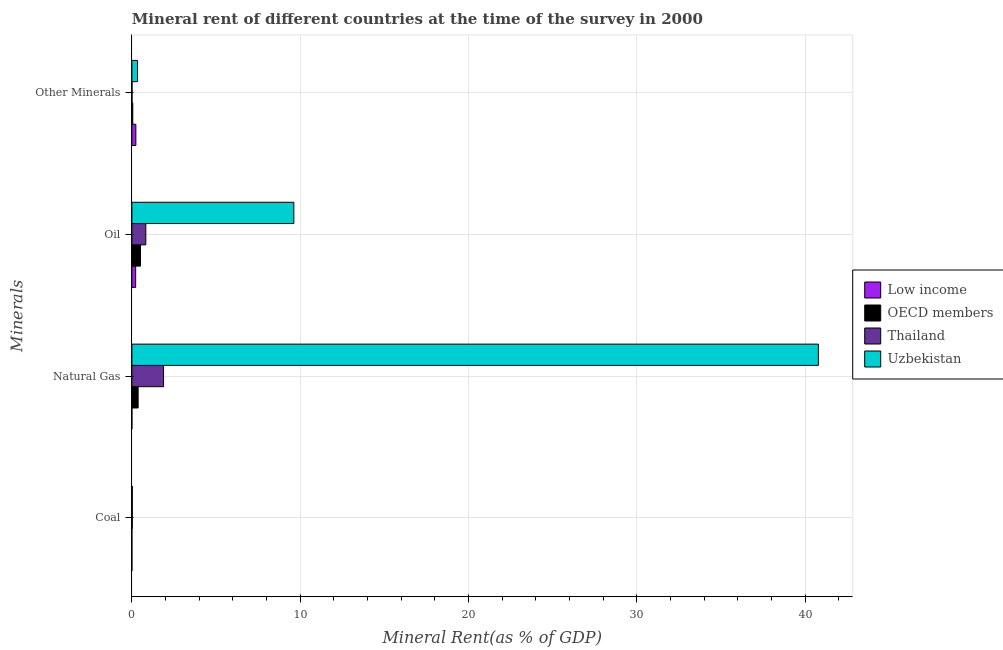How many different coloured bars are there?
Your answer should be compact. 4. Are the number of bars per tick equal to the number of legend labels?
Your response must be concise. Yes. Are the number of bars on each tick of the Y-axis equal?
Keep it short and to the point. Yes. How many bars are there on the 3rd tick from the bottom?
Give a very brief answer. 4. What is the label of the 1st group of bars from the top?
Give a very brief answer. Other Minerals. What is the oil rent in OECD members?
Offer a terse response. 0.51. Across all countries, what is the maximum coal rent?
Provide a succinct answer. 0.03. Across all countries, what is the minimum  rent of other minerals?
Offer a terse response. 0.01. In which country was the  rent of other minerals maximum?
Give a very brief answer. Uzbekistan. What is the total natural gas rent in the graph?
Your answer should be compact. 43.04. What is the difference between the oil rent in Low income and that in Thailand?
Keep it short and to the point. -0.6. What is the difference between the  rent of other minerals in Low income and the natural gas rent in Thailand?
Keep it short and to the point. -1.64. What is the average  rent of other minerals per country?
Make the answer very short. 0.16. What is the difference between the oil rent and  rent of other minerals in OECD members?
Make the answer very short. 0.46. What is the ratio of the coal rent in Thailand to that in Uzbekistan?
Your response must be concise. 1. Is the  rent of other minerals in Low income less than that in Uzbekistan?
Offer a terse response. Yes. What is the difference between the highest and the second highest natural gas rent?
Give a very brief answer. 38.9. What is the difference between the highest and the lowest coal rent?
Your answer should be compact. 0.03. Is the sum of the oil rent in Low income and OECD members greater than the maximum natural gas rent across all countries?
Offer a terse response. No. What does the 3rd bar from the top in Oil represents?
Provide a short and direct response. OECD members. What does the 1st bar from the bottom in Oil represents?
Your answer should be compact. Low income. Does the graph contain grids?
Keep it short and to the point. Yes. Where does the legend appear in the graph?
Ensure brevity in your answer.  Center right. What is the title of the graph?
Offer a very short reply. Mineral rent of different countries at the time of the survey in 2000. Does "Azerbaijan" appear as one of the legend labels in the graph?
Keep it short and to the point. No. What is the label or title of the X-axis?
Offer a very short reply. Mineral Rent(as % of GDP). What is the label or title of the Y-axis?
Provide a short and direct response. Minerals. What is the Mineral Rent(as % of GDP) of Low income in Coal?
Give a very brief answer. 3.43081541094935e-5. What is the Mineral Rent(as % of GDP) in OECD members in Coal?
Offer a terse response. 0. What is the Mineral Rent(as % of GDP) of Thailand in Coal?
Provide a short and direct response. 0.03. What is the Mineral Rent(as % of GDP) in Uzbekistan in Coal?
Keep it short and to the point. 0.03. What is the Mineral Rent(as % of GDP) in Low income in Natural Gas?
Provide a succinct answer. 0. What is the Mineral Rent(as % of GDP) of OECD members in Natural Gas?
Keep it short and to the point. 0.37. What is the Mineral Rent(as % of GDP) in Thailand in Natural Gas?
Your response must be concise. 1.88. What is the Mineral Rent(as % of GDP) in Uzbekistan in Natural Gas?
Offer a very short reply. 40.78. What is the Mineral Rent(as % of GDP) of Low income in Oil?
Make the answer very short. 0.22. What is the Mineral Rent(as % of GDP) in OECD members in Oil?
Your answer should be compact. 0.51. What is the Mineral Rent(as % of GDP) of Thailand in Oil?
Provide a succinct answer. 0.83. What is the Mineral Rent(as % of GDP) in Uzbekistan in Oil?
Provide a succinct answer. 9.62. What is the Mineral Rent(as % of GDP) in Low income in Other Minerals?
Give a very brief answer. 0.24. What is the Mineral Rent(as % of GDP) of OECD members in Other Minerals?
Your answer should be compact. 0.05. What is the Mineral Rent(as % of GDP) of Thailand in Other Minerals?
Give a very brief answer. 0.01. What is the Mineral Rent(as % of GDP) of Uzbekistan in Other Minerals?
Your response must be concise. 0.34. Across all Minerals, what is the maximum Mineral Rent(as % of GDP) of Low income?
Offer a very short reply. 0.24. Across all Minerals, what is the maximum Mineral Rent(as % of GDP) of OECD members?
Provide a succinct answer. 0.51. Across all Minerals, what is the maximum Mineral Rent(as % of GDP) of Thailand?
Offer a very short reply. 1.88. Across all Minerals, what is the maximum Mineral Rent(as % of GDP) of Uzbekistan?
Offer a very short reply. 40.78. Across all Minerals, what is the minimum Mineral Rent(as % of GDP) of Low income?
Your answer should be compact. 3.43081541094935e-5. Across all Minerals, what is the minimum Mineral Rent(as % of GDP) in OECD members?
Make the answer very short. 0. Across all Minerals, what is the minimum Mineral Rent(as % of GDP) in Thailand?
Give a very brief answer. 0.01. Across all Minerals, what is the minimum Mineral Rent(as % of GDP) of Uzbekistan?
Ensure brevity in your answer.  0.03. What is the total Mineral Rent(as % of GDP) in Low income in the graph?
Your answer should be compact. 0.46. What is the total Mineral Rent(as % of GDP) in OECD members in the graph?
Offer a terse response. 0.94. What is the total Mineral Rent(as % of GDP) of Thailand in the graph?
Provide a short and direct response. 2.74. What is the total Mineral Rent(as % of GDP) of Uzbekistan in the graph?
Give a very brief answer. 50.77. What is the difference between the Mineral Rent(as % of GDP) of Low income in Coal and that in Natural Gas?
Give a very brief answer. -0. What is the difference between the Mineral Rent(as % of GDP) of OECD members in Coal and that in Natural Gas?
Your answer should be compact. -0.37. What is the difference between the Mineral Rent(as % of GDP) of Thailand in Coal and that in Natural Gas?
Give a very brief answer. -1.86. What is the difference between the Mineral Rent(as % of GDP) in Uzbekistan in Coal and that in Natural Gas?
Provide a succinct answer. -40.76. What is the difference between the Mineral Rent(as % of GDP) of Low income in Coal and that in Oil?
Provide a short and direct response. -0.22. What is the difference between the Mineral Rent(as % of GDP) in OECD members in Coal and that in Oil?
Your response must be concise. -0.51. What is the difference between the Mineral Rent(as % of GDP) of Thailand in Coal and that in Oil?
Offer a very short reply. -0.8. What is the difference between the Mineral Rent(as % of GDP) in Uzbekistan in Coal and that in Oil?
Provide a succinct answer. -9.6. What is the difference between the Mineral Rent(as % of GDP) in Low income in Coal and that in Other Minerals?
Keep it short and to the point. -0.24. What is the difference between the Mineral Rent(as % of GDP) in OECD members in Coal and that in Other Minerals?
Give a very brief answer. -0.05. What is the difference between the Mineral Rent(as % of GDP) of Thailand in Coal and that in Other Minerals?
Ensure brevity in your answer.  0.02. What is the difference between the Mineral Rent(as % of GDP) in Uzbekistan in Coal and that in Other Minerals?
Ensure brevity in your answer.  -0.31. What is the difference between the Mineral Rent(as % of GDP) of Low income in Natural Gas and that in Oil?
Your response must be concise. -0.22. What is the difference between the Mineral Rent(as % of GDP) of OECD members in Natural Gas and that in Oil?
Give a very brief answer. -0.14. What is the difference between the Mineral Rent(as % of GDP) of Thailand in Natural Gas and that in Oil?
Provide a succinct answer. 1.05. What is the difference between the Mineral Rent(as % of GDP) in Uzbekistan in Natural Gas and that in Oil?
Provide a short and direct response. 31.16. What is the difference between the Mineral Rent(as % of GDP) in Low income in Natural Gas and that in Other Minerals?
Make the answer very short. -0.24. What is the difference between the Mineral Rent(as % of GDP) of OECD members in Natural Gas and that in Other Minerals?
Keep it short and to the point. 0.32. What is the difference between the Mineral Rent(as % of GDP) in Thailand in Natural Gas and that in Other Minerals?
Provide a short and direct response. 1.87. What is the difference between the Mineral Rent(as % of GDP) of Uzbekistan in Natural Gas and that in Other Minerals?
Offer a very short reply. 40.45. What is the difference between the Mineral Rent(as % of GDP) in Low income in Oil and that in Other Minerals?
Provide a short and direct response. -0.01. What is the difference between the Mineral Rent(as % of GDP) of OECD members in Oil and that in Other Minerals?
Your answer should be compact. 0.46. What is the difference between the Mineral Rent(as % of GDP) in Thailand in Oil and that in Other Minerals?
Offer a very short reply. 0.82. What is the difference between the Mineral Rent(as % of GDP) in Uzbekistan in Oil and that in Other Minerals?
Give a very brief answer. 9.29. What is the difference between the Mineral Rent(as % of GDP) in Low income in Coal and the Mineral Rent(as % of GDP) in OECD members in Natural Gas?
Your response must be concise. -0.37. What is the difference between the Mineral Rent(as % of GDP) of Low income in Coal and the Mineral Rent(as % of GDP) of Thailand in Natural Gas?
Ensure brevity in your answer.  -1.88. What is the difference between the Mineral Rent(as % of GDP) of Low income in Coal and the Mineral Rent(as % of GDP) of Uzbekistan in Natural Gas?
Give a very brief answer. -40.78. What is the difference between the Mineral Rent(as % of GDP) in OECD members in Coal and the Mineral Rent(as % of GDP) in Thailand in Natural Gas?
Provide a succinct answer. -1.88. What is the difference between the Mineral Rent(as % of GDP) of OECD members in Coal and the Mineral Rent(as % of GDP) of Uzbekistan in Natural Gas?
Offer a terse response. -40.78. What is the difference between the Mineral Rent(as % of GDP) of Thailand in Coal and the Mineral Rent(as % of GDP) of Uzbekistan in Natural Gas?
Offer a very short reply. -40.76. What is the difference between the Mineral Rent(as % of GDP) in Low income in Coal and the Mineral Rent(as % of GDP) in OECD members in Oil?
Keep it short and to the point. -0.51. What is the difference between the Mineral Rent(as % of GDP) in Low income in Coal and the Mineral Rent(as % of GDP) in Thailand in Oil?
Ensure brevity in your answer.  -0.83. What is the difference between the Mineral Rent(as % of GDP) of Low income in Coal and the Mineral Rent(as % of GDP) of Uzbekistan in Oil?
Keep it short and to the point. -9.62. What is the difference between the Mineral Rent(as % of GDP) in OECD members in Coal and the Mineral Rent(as % of GDP) in Thailand in Oil?
Offer a terse response. -0.83. What is the difference between the Mineral Rent(as % of GDP) in OECD members in Coal and the Mineral Rent(as % of GDP) in Uzbekistan in Oil?
Your response must be concise. -9.62. What is the difference between the Mineral Rent(as % of GDP) of Thailand in Coal and the Mineral Rent(as % of GDP) of Uzbekistan in Oil?
Your response must be concise. -9.6. What is the difference between the Mineral Rent(as % of GDP) in Low income in Coal and the Mineral Rent(as % of GDP) in OECD members in Other Minerals?
Offer a terse response. -0.05. What is the difference between the Mineral Rent(as % of GDP) in Low income in Coal and the Mineral Rent(as % of GDP) in Thailand in Other Minerals?
Your answer should be compact. -0.01. What is the difference between the Mineral Rent(as % of GDP) of Low income in Coal and the Mineral Rent(as % of GDP) of Uzbekistan in Other Minerals?
Your answer should be compact. -0.34. What is the difference between the Mineral Rent(as % of GDP) in OECD members in Coal and the Mineral Rent(as % of GDP) in Thailand in Other Minerals?
Your answer should be very brief. -0.01. What is the difference between the Mineral Rent(as % of GDP) of OECD members in Coal and the Mineral Rent(as % of GDP) of Uzbekistan in Other Minerals?
Keep it short and to the point. -0.34. What is the difference between the Mineral Rent(as % of GDP) of Thailand in Coal and the Mineral Rent(as % of GDP) of Uzbekistan in Other Minerals?
Offer a very short reply. -0.31. What is the difference between the Mineral Rent(as % of GDP) of Low income in Natural Gas and the Mineral Rent(as % of GDP) of OECD members in Oil?
Your answer should be compact. -0.51. What is the difference between the Mineral Rent(as % of GDP) of Low income in Natural Gas and the Mineral Rent(as % of GDP) of Thailand in Oil?
Provide a short and direct response. -0.83. What is the difference between the Mineral Rent(as % of GDP) in Low income in Natural Gas and the Mineral Rent(as % of GDP) in Uzbekistan in Oil?
Keep it short and to the point. -9.62. What is the difference between the Mineral Rent(as % of GDP) of OECD members in Natural Gas and the Mineral Rent(as % of GDP) of Thailand in Oil?
Your response must be concise. -0.46. What is the difference between the Mineral Rent(as % of GDP) of OECD members in Natural Gas and the Mineral Rent(as % of GDP) of Uzbekistan in Oil?
Offer a very short reply. -9.25. What is the difference between the Mineral Rent(as % of GDP) of Thailand in Natural Gas and the Mineral Rent(as % of GDP) of Uzbekistan in Oil?
Provide a short and direct response. -7.74. What is the difference between the Mineral Rent(as % of GDP) of Low income in Natural Gas and the Mineral Rent(as % of GDP) of OECD members in Other Minerals?
Make the answer very short. -0.05. What is the difference between the Mineral Rent(as % of GDP) in Low income in Natural Gas and the Mineral Rent(as % of GDP) in Thailand in Other Minerals?
Keep it short and to the point. -0.01. What is the difference between the Mineral Rent(as % of GDP) of Low income in Natural Gas and the Mineral Rent(as % of GDP) of Uzbekistan in Other Minerals?
Make the answer very short. -0.34. What is the difference between the Mineral Rent(as % of GDP) in OECD members in Natural Gas and the Mineral Rent(as % of GDP) in Thailand in Other Minerals?
Your answer should be compact. 0.36. What is the difference between the Mineral Rent(as % of GDP) of OECD members in Natural Gas and the Mineral Rent(as % of GDP) of Uzbekistan in Other Minerals?
Provide a succinct answer. 0.04. What is the difference between the Mineral Rent(as % of GDP) in Thailand in Natural Gas and the Mineral Rent(as % of GDP) in Uzbekistan in Other Minerals?
Your answer should be compact. 1.55. What is the difference between the Mineral Rent(as % of GDP) in Low income in Oil and the Mineral Rent(as % of GDP) in OECD members in Other Minerals?
Your answer should be compact. 0.17. What is the difference between the Mineral Rent(as % of GDP) in Low income in Oil and the Mineral Rent(as % of GDP) in Thailand in Other Minerals?
Your response must be concise. 0.21. What is the difference between the Mineral Rent(as % of GDP) of Low income in Oil and the Mineral Rent(as % of GDP) of Uzbekistan in Other Minerals?
Ensure brevity in your answer.  -0.11. What is the difference between the Mineral Rent(as % of GDP) of OECD members in Oil and the Mineral Rent(as % of GDP) of Thailand in Other Minerals?
Ensure brevity in your answer.  0.5. What is the difference between the Mineral Rent(as % of GDP) in OECD members in Oil and the Mineral Rent(as % of GDP) in Uzbekistan in Other Minerals?
Offer a very short reply. 0.18. What is the difference between the Mineral Rent(as % of GDP) of Thailand in Oil and the Mineral Rent(as % of GDP) of Uzbekistan in Other Minerals?
Your answer should be very brief. 0.49. What is the average Mineral Rent(as % of GDP) in Low income per Minerals?
Provide a succinct answer. 0.12. What is the average Mineral Rent(as % of GDP) in OECD members per Minerals?
Keep it short and to the point. 0.23. What is the average Mineral Rent(as % of GDP) in Thailand per Minerals?
Provide a short and direct response. 0.69. What is the average Mineral Rent(as % of GDP) of Uzbekistan per Minerals?
Make the answer very short. 12.69. What is the difference between the Mineral Rent(as % of GDP) in Low income and Mineral Rent(as % of GDP) in OECD members in Coal?
Ensure brevity in your answer.  -0. What is the difference between the Mineral Rent(as % of GDP) in Low income and Mineral Rent(as % of GDP) in Thailand in Coal?
Your answer should be very brief. -0.03. What is the difference between the Mineral Rent(as % of GDP) of Low income and Mineral Rent(as % of GDP) of Uzbekistan in Coal?
Give a very brief answer. -0.03. What is the difference between the Mineral Rent(as % of GDP) in OECD members and Mineral Rent(as % of GDP) in Thailand in Coal?
Your answer should be very brief. -0.03. What is the difference between the Mineral Rent(as % of GDP) in OECD members and Mineral Rent(as % of GDP) in Uzbekistan in Coal?
Your answer should be very brief. -0.03. What is the difference between the Mineral Rent(as % of GDP) in Thailand and Mineral Rent(as % of GDP) in Uzbekistan in Coal?
Give a very brief answer. -0. What is the difference between the Mineral Rent(as % of GDP) of Low income and Mineral Rent(as % of GDP) of OECD members in Natural Gas?
Your answer should be very brief. -0.37. What is the difference between the Mineral Rent(as % of GDP) of Low income and Mineral Rent(as % of GDP) of Thailand in Natural Gas?
Ensure brevity in your answer.  -1.88. What is the difference between the Mineral Rent(as % of GDP) in Low income and Mineral Rent(as % of GDP) in Uzbekistan in Natural Gas?
Ensure brevity in your answer.  -40.78. What is the difference between the Mineral Rent(as % of GDP) of OECD members and Mineral Rent(as % of GDP) of Thailand in Natural Gas?
Provide a succinct answer. -1.51. What is the difference between the Mineral Rent(as % of GDP) in OECD members and Mineral Rent(as % of GDP) in Uzbekistan in Natural Gas?
Give a very brief answer. -40.41. What is the difference between the Mineral Rent(as % of GDP) in Thailand and Mineral Rent(as % of GDP) in Uzbekistan in Natural Gas?
Offer a terse response. -38.9. What is the difference between the Mineral Rent(as % of GDP) in Low income and Mineral Rent(as % of GDP) in OECD members in Oil?
Your answer should be very brief. -0.29. What is the difference between the Mineral Rent(as % of GDP) of Low income and Mineral Rent(as % of GDP) of Thailand in Oil?
Provide a succinct answer. -0.6. What is the difference between the Mineral Rent(as % of GDP) in Low income and Mineral Rent(as % of GDP) in Uzbekistan in Oil?
Ensure brevity in your answer.  -9.4. What is the difference between the Mineral Rent(as % of GDP) of OECD members and Mineral Rent(as % of GDP) of Thailand in Oil?
Ensure brevity in your answer.  -0.32. What is the difference between the Mineral Rent(as % of GDP) of OECD members and Mineral Rent(as % of GDP) of Uzbekistan in Oil?
Offer a terse response. -9.11. What is the difference between the Mineral Rent(as % of GDP) in Thailand and Mineral Rent(as % of GDP) in Uzbekistan in Oil?
Offer a terse response. -8.79. What is the difference between the Mineral Rent(as % of GDP) in Low income and Mineral Rent(as % of GDP) in OECD members in Other Minerals?
Make the answer very short. 0.18. What is the difference between the Mineral Rent(as % of GDP) of Low income and Mineral Rent(as % of GDP) of Thailand in Other Minerals?
Your answer should be very brief. 0.23. What is the difference between the Mineral Rent(as % of GDP) of Low income and Mineral Rent(as % of GDP) of Uzbekistan in Other Minerals?
Your response must be concise. -0.1. What is the difference between the Mineral Rent(as % of GDP) of OECD members and Mineral Rent(as % of GDP) of Thailand in Other Minerals?
Ensure brevity in your answer.  0.04. What is the difference between the Mineral Rent(as % of GDP) in OECD members and Mineral Rent(as % of GDP) in Uzbekistan in Other Minerals?
Provide a succinct answer. -0.28. What is the difference between the Mineral Rent(as % of GDP) in Thailand and Mineral Rent(as % of GDP) in Uzbekistan in Other Minerals?
Offer a very short reply. -0.33. What is the ratio of the Mineral Rent(as % of GDP) in Low income in Coal to that in Natural Gas?
Your response must be concise. 0.23. What is the ratio of the Mineral Rent(as % of GDP) of Thailand in Coal to that in Natural Gas?
Provide a short and direct response. 0.01. What is the ratio of the Mineral Rent(as % of GDP) in Uzbekistan in Coal to that in Natural Gas?
Provide a short and direct response. 0. What is the ratio of the Mineral Rent(as % of GDP) in OECD members in Coal to that in Oil?
Your answer should be very brief. 0. What is the ratio of the Mineral Rent(as % of GDP) in Thailand in Coal to that in Oil?
Keep it short and to the point. 0.03. What is the ratio of the Mineral Rent(as % of GDP) of Uzbekistan in Coal to that in Oil?
Make the answer very short. 0. What is the ratio of the Mineral Rent(as % of GDP) in OECD members in Coal to that in Other Minerals?
Offer a terse response. 0. What is the ratio of the Mineral Rent(as % of GDP) in Thailand in Coal to that in Other Minerals?
Provide a short and direct response. 2.59. What is the ratio of the Mineral Rent(as % of GDP) in Uzbekistan in Coal to that in Other Minerals?
Your answer should be very brief. 0.08. What is the ratio of the Mineral Rent(as % of GDP) of Low income in Natural Gas to that in Oil?
Your answer should be compact. 0. What is the ratio of the Mineral Rent(as % of GDP) in OECD members in Natural Gas to that in Oil?
Your response must be concise. 0.73. What is the ratio of the Mineral Rent(as % of GDP) of Thailand in Natural Gas to that in Oil?
Ensure brevity in your answer.  2.27. What is the ratio of the Mineral Rent(as % of GDP) in Uzbekistan in Natural Gas to that in Oil?
Provide a short and direct response. 4.24. What is the ratio of the Mineral Rent(as % of GDP) in Low income in Natural Gas to that in Other Minerals?
Provide a short and direct response. 0. What is the ratio of the Mineral Rent(as % of GDP) of OECD members in Natural Gas to that in Other Minerals?
Keep it short and to the point. 7.03. What is the ratio of the Mineral Rent(as % of GDP) in Thailand in Natural Gas to that in Other Minerals?
Provide a short and direct response. 192.81. What is the ratio of the Mineral Rent(as % of GDP) in Uzbekistan in Natural Gas to that in Other Minerals?
Provide a succinct answer. 121.68. What is the ratio of the Mineral Rent(as % of GDP) of Low income in Oil to that in Other Minerals?
Your answer should be very brief. 0.95. What is the ratio of the Mineral Rent(as % of GDP) of OECD members in Oil to that in Other Minerals?
Keep it short and to the point. 9.69. What is the ratio of the Mineral Rent(as % of GDP) in Thailand in Oil to that in Other Minerals?
Offer a very short reply. 84.9. What is the ratio of the Mineral Rent(as % of GDP) of Uzbekistan in Oil to that in Other Minerals?
Give a very brief answer. 28.71. What is the difference between the highest and the second highest Mineral Rent(as % of GDP) in Low income?
Keep it short and to the point. 0.01. What is the difference between the highest and the second highest Mineral Rent(as % of GDP) in OECD members?
Ensure brevity in your answer.  0.14. What is the difference between the highest and the second highest Mineral Rent(as % of GDP) of Thailand?
Offer a terse response. 1.05. What is the difference between the highest and the second highest Mineral Rent(as % of GDP) of Uzbekistan?
Keep it short and to the point. 31.16. What is the difference between the highest and the lowest Mineral Rent(as % of GDP) in Low income?
Provide a short and direct response. 0.24. What is the difference between the highest and the lowest Mineral Rent(as % of GDP) of OECD members?
Make the answer very short. 0.51. What is the difference between the highest and the lowest Mineral Rent(as % of GDP) of Thailand?
Give a very brief answer. 1.87. What is the difference between the highest and the lowest Mineral Rent(as % of GDP) in Uzbekistan?
Offer a very short reply. 40.76. 